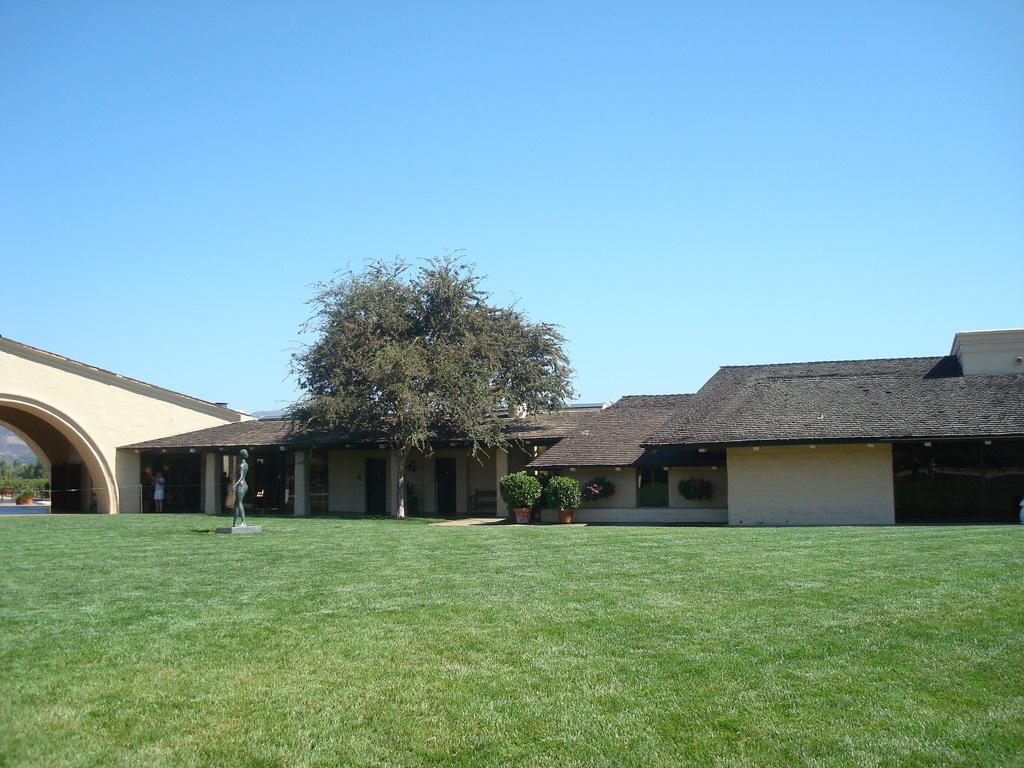What type of structures can be seen in the image? There are houses in the image. What type of vegetation is present in the image? There are trees in the image. What type of ground cover is visible at the bottom of the image? There is grass at the bottom of the image. What is visible at the top of the image? The sky is visible at the top of the image. Can you tell me how many eggs are hidden in the trees in the image? There are no eggs present in the image; it features houses, trees, grass, and the sky. Is there any magic happening in the image? There is no indication of magic in the image; it shows a natural scene with houses, trees, grass, and the sky. 